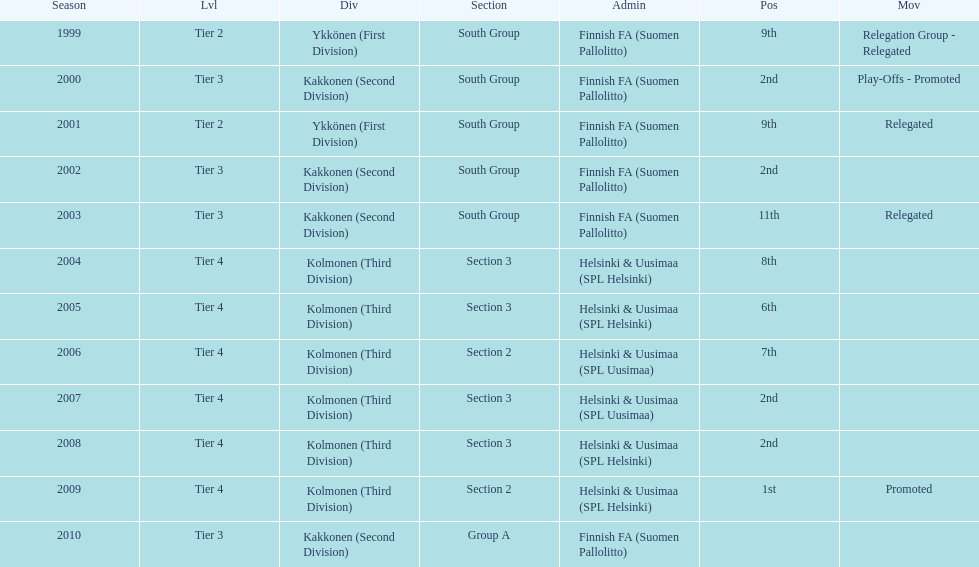Would you be able to parse every entry in this table? {'header': ['Season', 'Lvl', 'Div', 'Section', 'Admin', 'Pos', 'Mov'], 'rows': [['1999', 'Tier 2', 'Ykkönen (First Division)', 'South Group', 'Finnish FA (Suomen Pallolitto)', '9th', 'Relegation Group - Relegated'], ['2000', 'Tier 3', 'Kakkonen (Second Division)', 'South Group', 'Finnish FA (Suomen Pallolitto)', '2nd', 'Play-Offs - Promoted'], ['2001', 'Tier 2', 'Ykkönen (First Division)', 'South Group', 'Finnish FA (Suomen Pallolitto)', '9th', 'Relegated'], ['2002', 'Tier 3', 'Kakkonen (Second Division)', 'South Group', 'Finnish FA (Suomen Pallolitto)', '2nd', ''], ['2003', 'Tier 3', 'Kakkonen (Second Division)', 'South Group', 'Finnish FA (Suomen Pallolitto)', '11th', 'Relegated'], ['2004', 'Tier 4', 'Kolmonen (Third Division)', 'Section 3', 'Helsinki & Uusimaa (SPL Helsinki)', '8th', ''], ['2005', 'Tier 4', 'Kolmonen (Third Division)', 'Section 3', 'Helsinki & Uusimaa (SPL Helsinki)', '6th', ''], ['2006', 'Tier 4', 'Kolmonen (Third Division)', 'Section 2', 'Helsinki & Uusimaa (SPL Uusimaa)', '7th', ''], ['2007', 'Tier 4', 'Kolmonen (Third Division)', 'Section 3', 'Helsinki & Uusimaa (SPL Uusimaa)', '2nd', ''], ['2008', 'Tier 4', 'Kolmonen (Third Division)', 'Section 3', 'Helsinki & Uusimaa (SPL Helsinki)', '2nd', ''], ['2009', 'Tier 4', 'Kolmonen (Third Division)', 'Section 2', 'Helsinki & Uusimaa (SPL Helsinki)', '1st', 'Promoted'], ['2010', 'Tier 3', 'Kakkonen (Second Division)', 'Group A', 'Finnish FA (Suomen Pallolitto)', '', '']]} How many 2nd positions were there? 4. 